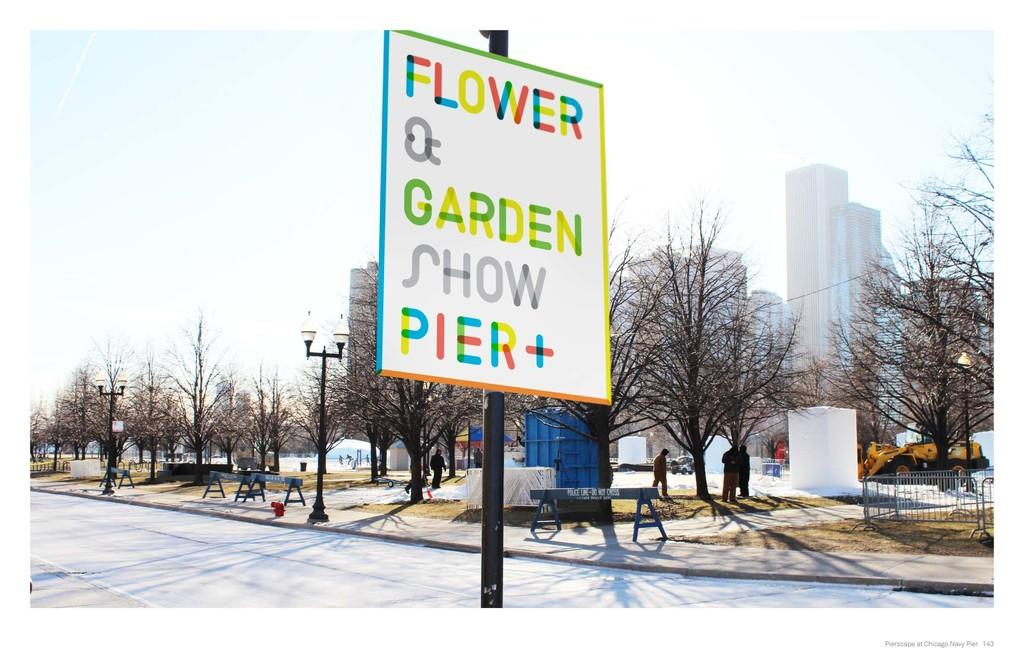<image>
Give a short and clear explanation of the subsequent image. Flower Garden Show Pier + sign on a pole outside. 